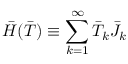Convert formula to latex. <formula><loc_0><loc_0><loc_500><loc_500>\bar { H } ( \bar { T } ) \equiv \sum _ { k = 1 } ^ { \infty } \bar { T } _ { k } \bar { J } _ { k }</formula> 